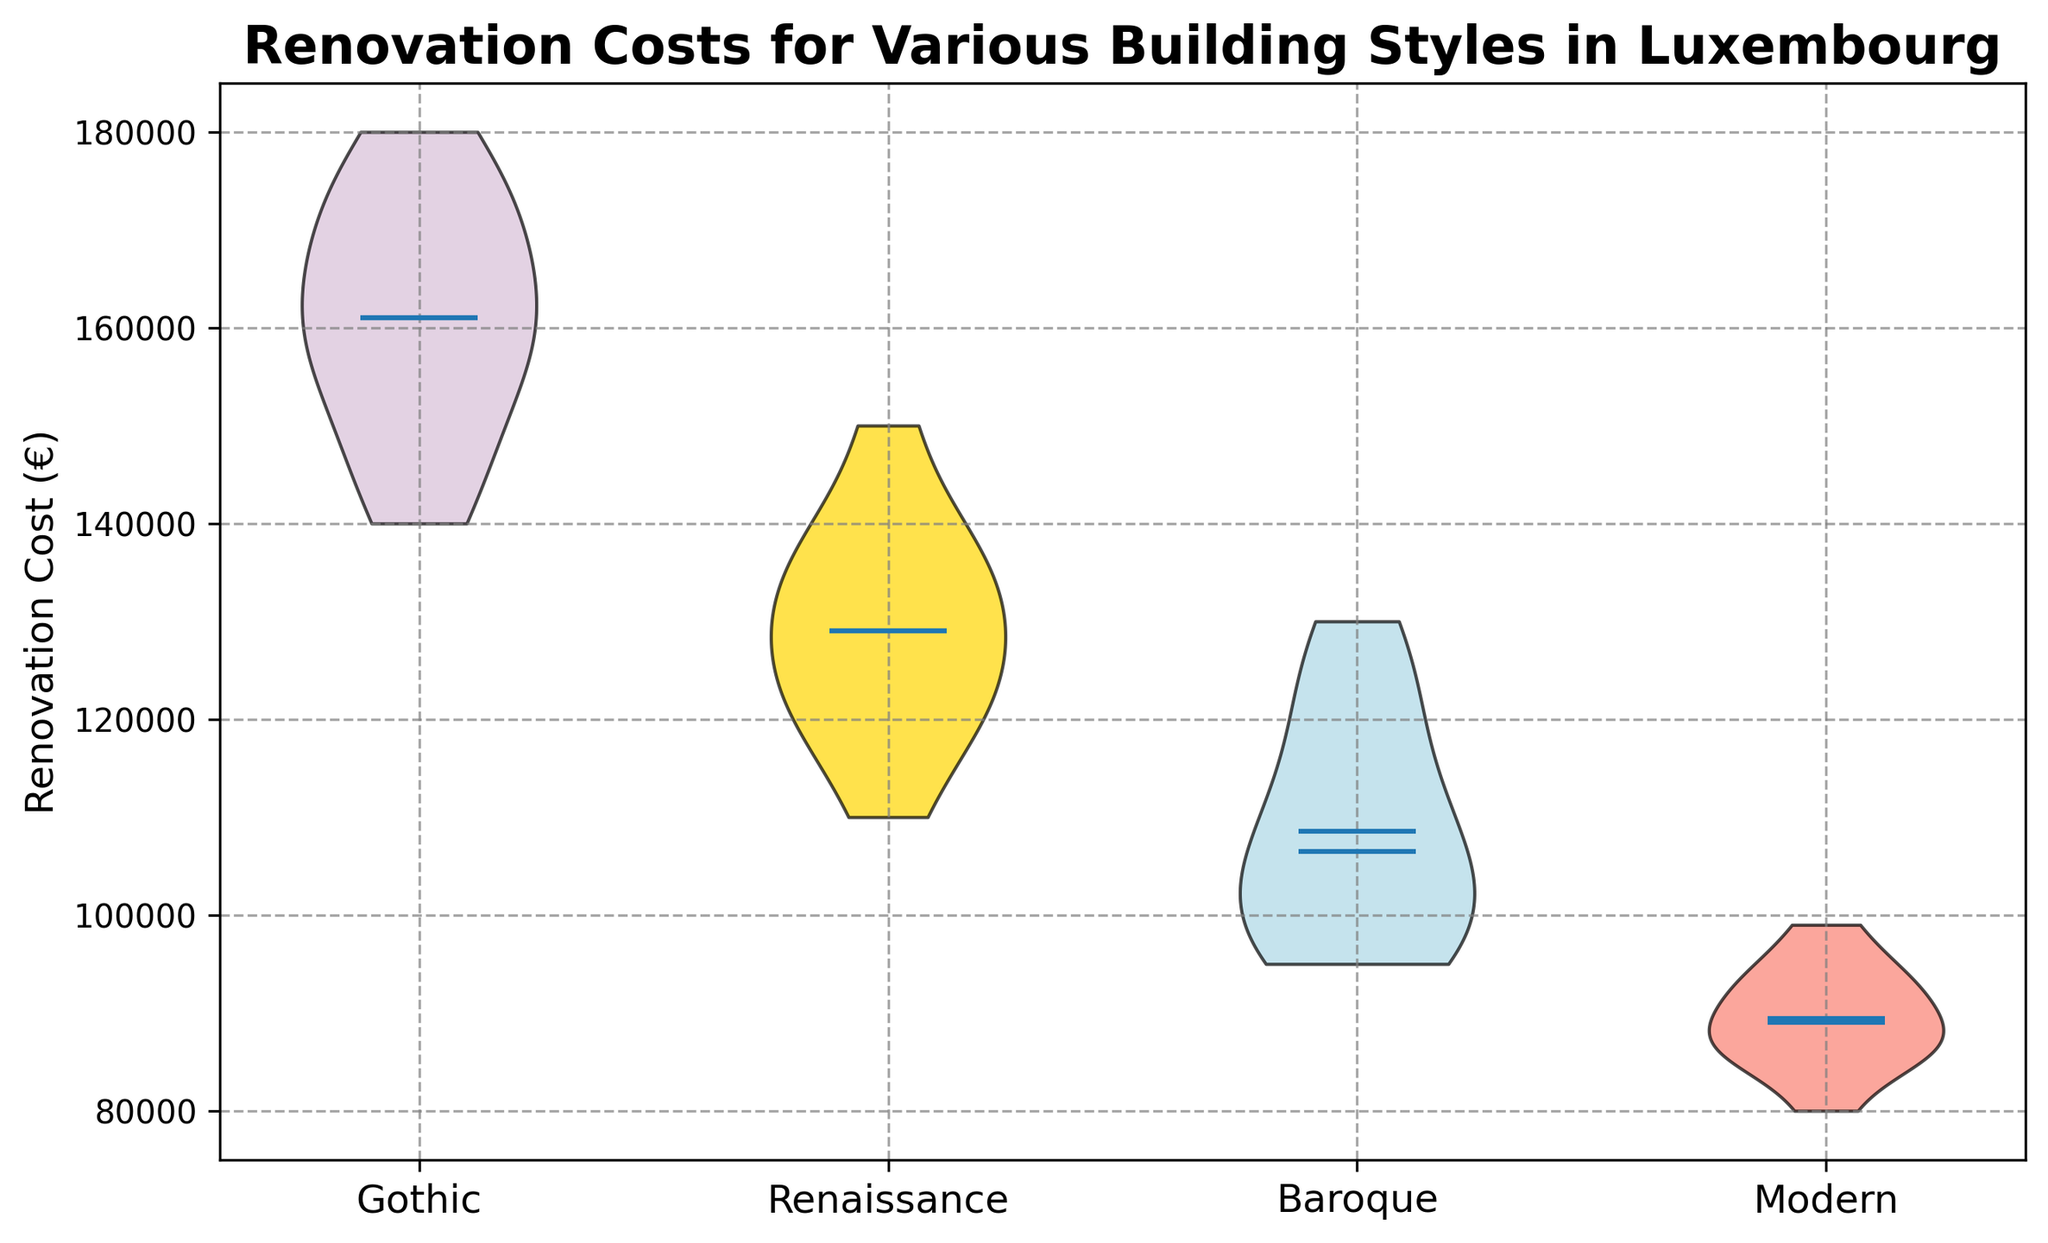Which building style has the highest median renovation cost? The median renovation cost is indicated by the horizontal lines within each violin plot. By comparing these lines across all styles, we see the Gothic style has the highest median line.
Answer: Gothic Which building style has the largest range of renovation costs? The range of renovation costs can be visually assessed by the height of the violin plots. The Gothic style has the tallest violin plot, indicating the largest range.
Answer: Gothic Which building style shows the least variability in renovation costs? Variability can be inferred from the width of the violin plots. The Modern style has the narrowest plot, indicating the least variability in renovation costs.
Answer: Modern How do the mean renovation costs for Gothic and Renaissance styles compare? The mean renovation costs are marked by the central points within the violin plots. The mean for Gothic style is higher than that of the Renaissance style.
Answer: Gothic is higher What is the median renovation cost for Modern buildings? The median value is the horizontal line inside the violin plot for Modern buildings, approximately at €88,000.
Answer: €88,000 Which two building styles have renovation costs with the most overlap? Overlap can be determined by comparing the spread of the violin plots. The Baroque and Renaissance styles have plots that show significant overlap in their distributions.
Answer: Baroque and Renaissance Are there any building styles where the renovation costs do not exceed €150,000? By checking the upper limits of the violin plots, it is observed that neither Baroque nor Modern styles exceed €150,000 in renovation costs.
Answer: Baroque and Modern Which building style displays renovation costs as low as €80,000? The Modern style's violin plot starts around €80,000, indicating it's the lowest in that range.
Answer: Modern By how much does the highest renovation cost in Gothic style exceed the highest cost in Modern style? The highest points of the violin plots for Gothic and Modern styles are approximately €180,000 and €99,000 respectively. The difference is €180,000 - €99,000 = €81,000.
Answer: €81,000 Is the mean renovation cost higher for Baroque or Renaissance buildings? The mean cost is indicated by the central markers. Comparing these, the Renaissance mean is slightly higher than that of Baroque.
Answer: Renaissance 